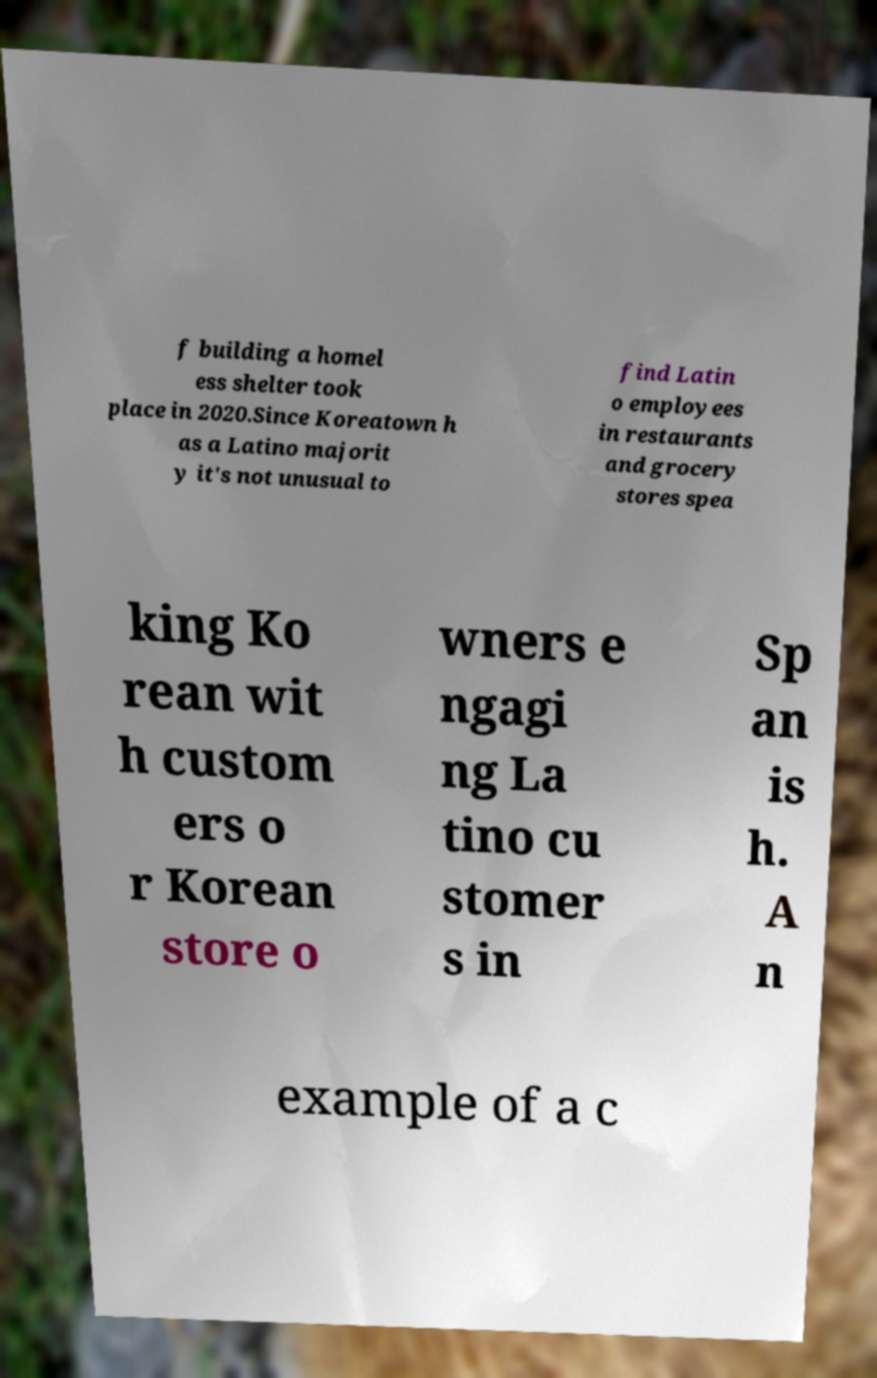Can you read and provide the text displayed in the image?This photo seems to have some interesting text. Can you extract and type it out for me? f building a homel ess shelter took place in 2020.Since Koreatown h as a Latino majorit y it's not unusual to find Latin o employees in restaurants and grocery stores spea king Ko rean wit h custom ers o r Korean store o wners e ngagi ng La tino cu stomer s in Sp an is h. A n example of a c 